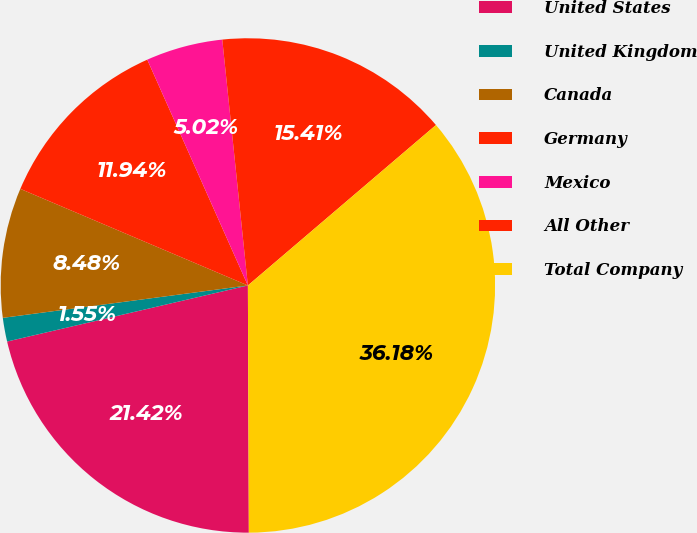Convert chart. <chart><loc_0><loc_0><loc_500><loc_500><pie_chart><fcel>United States<fcel>United Kingdom<fcel>Canada<fcel>Germany<fcel>Mexico<fcel>All Other<fcel>Total Company<nl><fcel>21.42%<fcel>1.55%<fcel>8.48%<fcel>11.94%<fcel>5.02%<fcel>15.41%<fcel>36.18%<nl></chart> 